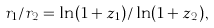Convert formula to latex. <formula><loc_0><loc_0><loc_500><loc_500>r _ { 1 } / r _ { 2 } = \ln ( 1 + z _ { 1 } ) / \ln ( 1 + z _ { 2 } ) ,</formula> 